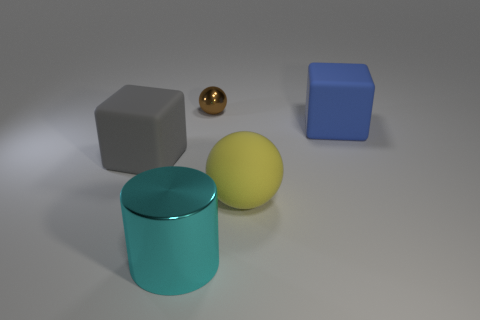What is the shape of the object that is the same material as the brown ball?
Your answer should be compact. Cylinder. Is the size of the blue matte thing the same as the yellow thing?
Offer a very short reply. Yes. What size is the metallic thing that is behind the cylinder that is to the left of the large sphere?
Offer a terse response. Small. How many cylinders are brown matte things or yellow things?
Your response must be concise. 0. Is the size of the cyan thing the same as the shiny thing that is behind the large cyan metallic thing?
Offer a terse response. No. Is the number of big blue matte cubes that are in front of the large cylinder greater than the number of small brown matte cubes?
Your answer should be compact. No. The blue block that is made of the same material as the big yellow sphere is what size?
Your answer should be compact. Large. Are there any big cylinders of the same color as the big rubber sphere?
Make the answer very short. No. How many objects are tiny shiny spheres or large objects that are on the left side of the large rubber sphere?
Ensure brevity in your answer.  3. Are there more large cylinders than large matte objects?
Make the answer very short. No. 